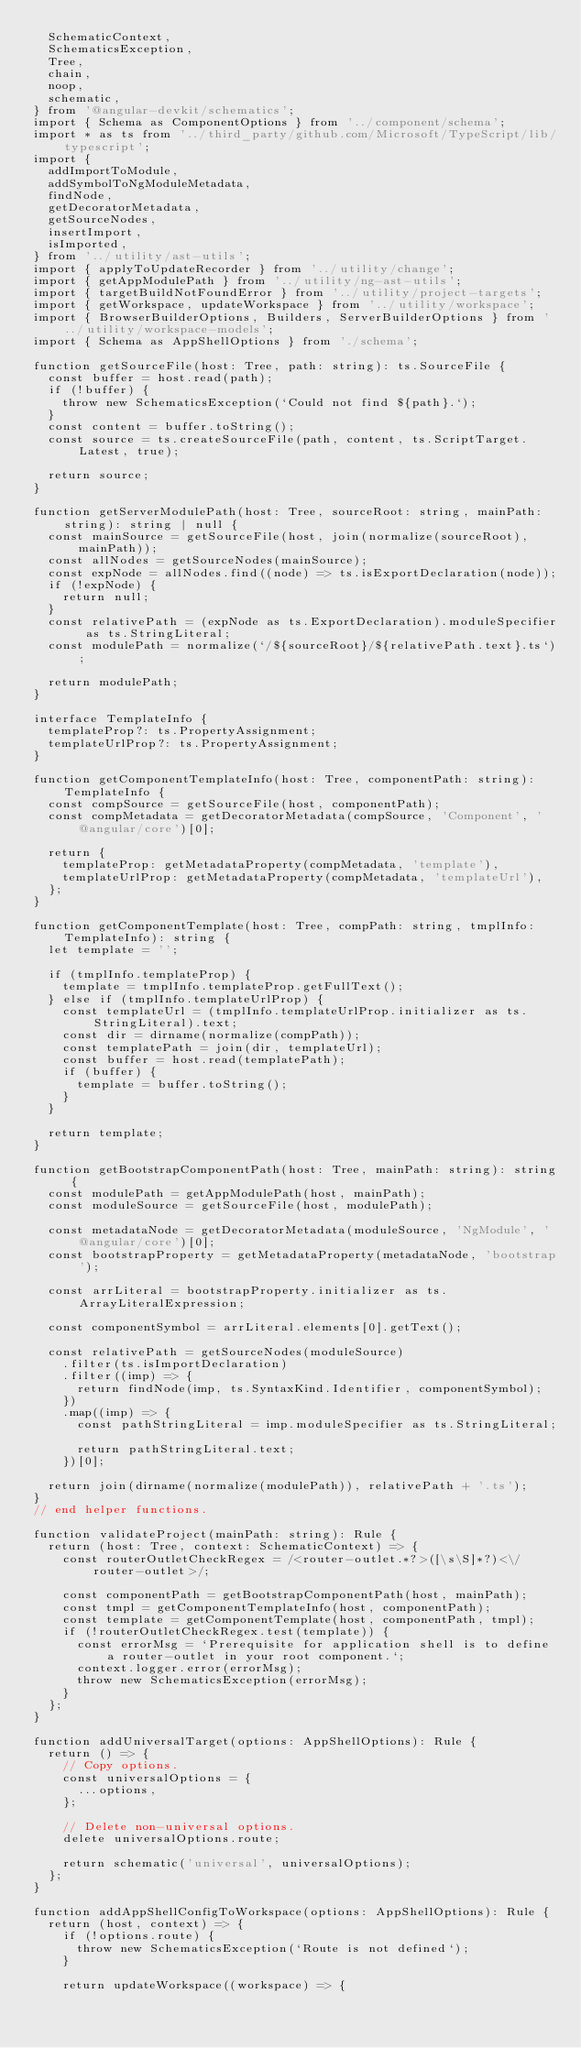Convert code to text. <code><loc_0><loc_0><loc_500><loc_500><_TypeScript_>  SchematicContext,
  SchematicsException,
  Tree,
  chain,
  noop,
  schematic,
} from '@angular-devkit/schematics';
import { Schema as ComponentOptions } from '../component/schema';
import * as ts from '../third_party/github.com/Microsoft/TypeScript/lib/typescript';
import {
  addImportToModule,
  addSymbolToNgModuleMetadata,
  findNode,
  getDecoratorMetadata,
  getSourceNodes,
  insertImport,
  isImported,
} from '../utility/ast-utils';
import { applyToUpdateRecorder } from '../utility/change';
import { getAppModulePath } from '../utility/ng-ast-utils';
import { targetBuildNotFoundError } from '../utility/project-targets';
import { getWorkspace, updateWorkspace } from '../utility/workspace';
import { BrowserBuilderOptions, Builders, ServerBuilderOptions } from '../utility/workspace-models';
import { Schema as AppShellOptions } from './schema';

function getSourceFile(host: Tree, path: string): ts.SourceFile {
  const buffer = host.read(path);
  if (!buffer) {
    throw new SchematicsException(`Could not find ${path}.`);
  }
  const content = buffer.toString();
  const source = ts.createSourceFile(path, content, ts.ScriptTarget.Latest, true);

  return source;
}

function getServerModulePath(host: Tree, sourceRoot: string, mainPath: string): string | null {
  const mainSource = getSourceFile(host, join(normalize(sourceRoot), mainPath));
  const allNodes = getSourceNodes(mainSource);
  const expNode = allNodes.find((node) => ts.isExportDeclaration(node));
  if (!expNode) {
    return null;
  }
  const relativePath = (expNode as ts.ExportDeclaration).moduleSpecifier as ts.StringLiteral;
  const modulePath = normalize(`/${sourceRoot}/${relativePath.text}.ts`);

  return modulePath;
}

interface TemplateInfo {
  templateProp?: ts.PropertyAssignment;
  templateUrlProp?: ts.PropertyAssignment;
}

function getComponentTemplateInfo(host: Tree, componentPath: string): TemplateInfo {
  const compSource = getSourceFile(host, componentPath);
  const compMetadata = getDecoratorMetadata(compSource, 'Component', '@angular/core')[0];

  return {
    templateProp: getMetadataProperty(compMetadata, 'template'),
    templateUrlProp: getMetadataProperty(compMetadata, 'templateUrl'),
  };
}

function getComponentTemplate(host: Tree, compPath: string, tmplInfo: TemplateInfo): string {
  let template = '';

  if (tmplInfo.templateProp) {
    template = tmplInfo.templateProp.getFullText();
  } else if (tmplInfo.templateUrlProp) {
    const templateUrl = (tmplInfo.templateUrlProp.initializer as ts.StringLiteral).text;
    const dir = dirname(normalize(compPath));
    const templatePath = join(dir, templateUrl);
    const buffer = host.read(templatePath);
    if (buffer) {
      template = buffer.toString();
    }
  }

  return template;
}

function getBootstrapComponentPath(host: Tree, mainPath: string): string {
  const modulePath = getAppModulePath(host, mainPath);
  const moduleSource = getSourceFile(host, modulePath);

  const metadataNode = getDecoratorMetadata(moduleSource, 'NgModule', '@angular/core')[0];
  const bootstrapProperty = getMetadataProperty(metadataNode, 'bootstrap');

  const arrLiteral = bootstrapProperty.initializer as ts.ArrayLiteralExpression;

  const componentSymbol = arrLiteral.elements[0].getText();

  const relativePath = getSourceNodes(moduleSource)
    .filter(ts.isImportDeclaration)
    .filter((imp) => {
      return findNode(imp, ts.SyntaxKind.Identifier, componentSymbol);
    })
    .map((imp) => {
      const pathStringLiteral = imp.moduleSpecifier as ts.StringLiteral;

      return pathStringLiteral.text;
    })[0];

  return join(dirname(normalize(modulePath)), relativePath + '.ts');
}
// end helper functions.

function validateProject(mainPath: string): Rule {
  return (host: Tree, context: SchematicContext) => {
    const routerOutletCheckRegex = /<router-outlet.*?>([\s\S]*?)<\/router-outlet>/;

    const componentPath = getBootstrapComponentPath(host, mainPath);
    const tmpl = getComponentTemplateInfo(host, componentPath);
    const template = getComponentTemplate(host, componentPath, tmpl);
    if (!routerOutletCheckRegex.test(template)) {
      const errorMsg = `Prerequisite for application shell is to define a router-outlet in your root component.`;
      context.logger.error(errorMsg);
      throw new SchematicsException(errorMsg);
    }
  };
}

function addUniversalTarget(options: AppShellOptions): Rule {
  return () => {
    // Copy options.
    const universalOptions = {
      ...options,
    };

    // Delete non-universal options.
    delete universalOptions.route;

    return schematic('universal', universalOptions);
  };
}

function addAppShellConfigToWorkspace(options: AppShellOptions): Rule {
  return (host, context) => {
    if (!options.route) {
      throw new SchematicsException(`Route is not defined`);
    }

    return updateWorkspace((workspace) => {</code> 